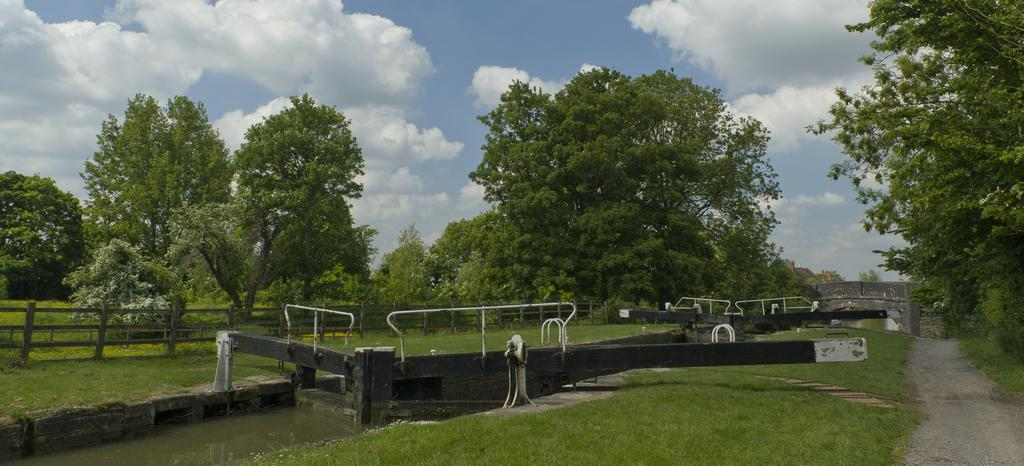What type of vegetation can be seen in the image? There are trees in the image. What body of water is present in the image? There is a canal in the image. What structure is present in the image that allows people to cross the canal? There is a bridge in the image. What type of barrier is present in the image? There is a wooden fence in the image. What type of ground cover is present in the image? Grass is present on the ground in the image. How would you describe the sky in the image? The sky is blue and cloudy in the image. Can you see a cannon being fired in the image? No, there is no cannon or any indication of a cannon being fired in the image. What type of support is the bridge providing in the image? The bridge is providing a means for people to cross the canal, not a support for any specific object or structure. 